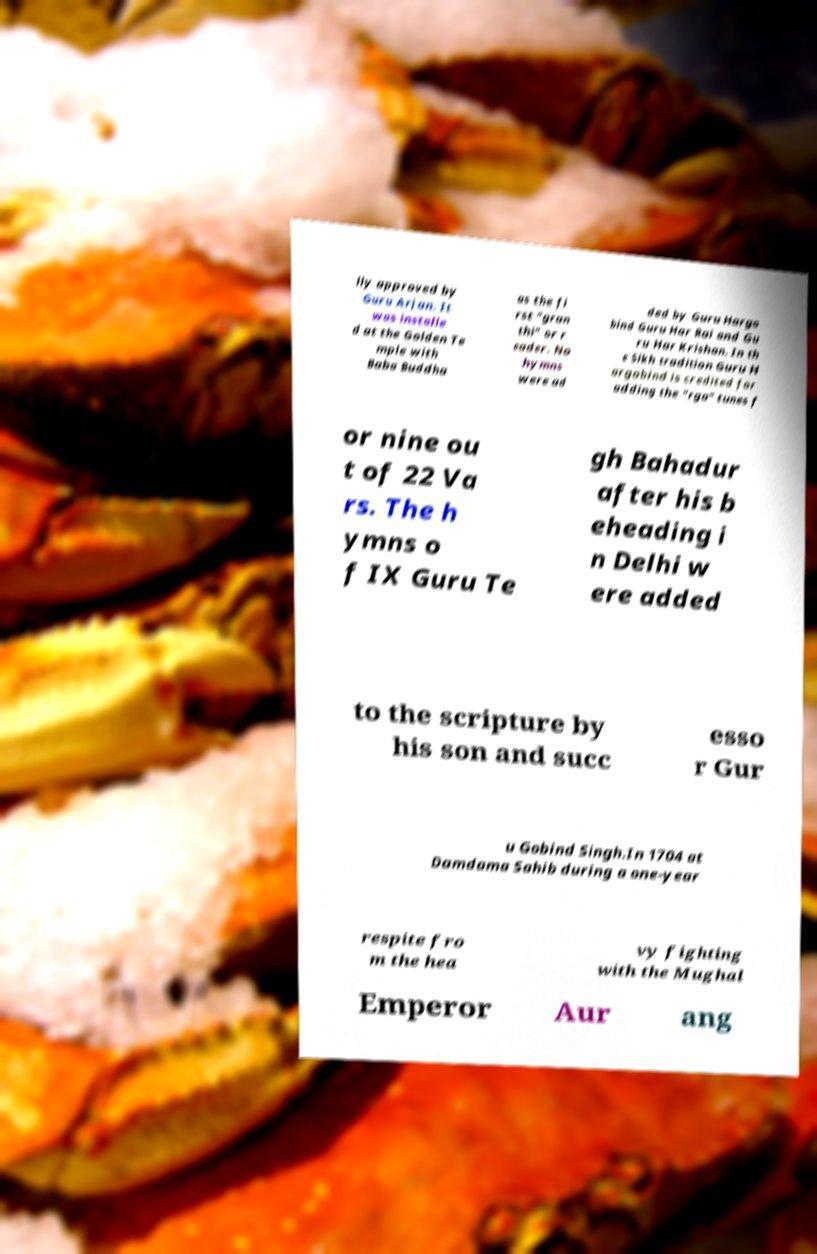There's text embedded in this image that I need extracted. Can you transcribe it verbatim? lly approved by Guru Arjan. It was installe d at the Golden Te mple with Baba Buddha as the fi rst "gran thi" or r eader. No hymns were ad ded by Guru Hargo bind Guru Har Rai and Gu ru Har Krishan. In th e Sikh tradition Guru H argobind is credited for adding the "rga" tunes f or nine ou t of 22 Va rs. The h ymns o f IX Guru Te gh Bahadur after his b eheading i n Delhi w ere added to the scripture by his son and succ esso r Gur u Gobind Singh.In 1704 at Damdama Sahib during a one-year respite fro m the hea vy fighting with the Mughal Emperor Aur ang 